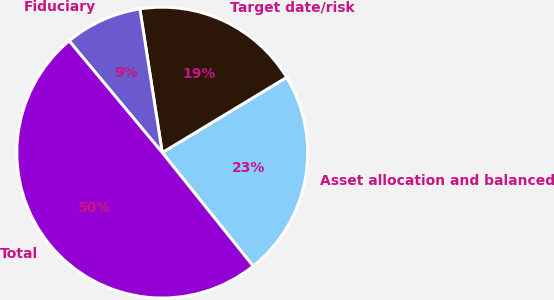Convert chart. <chart><loc_0><loc_0><loc_500><loc_500><pie_chart><fcel>Asset allocation and balanced<fcel>Target date/risk<fcel>Fiduciary<fcel>Total<nl><fcel>22.91%<fcel>18.8%<fcel>8.6%<fcel>49.69%<nl></chart> 